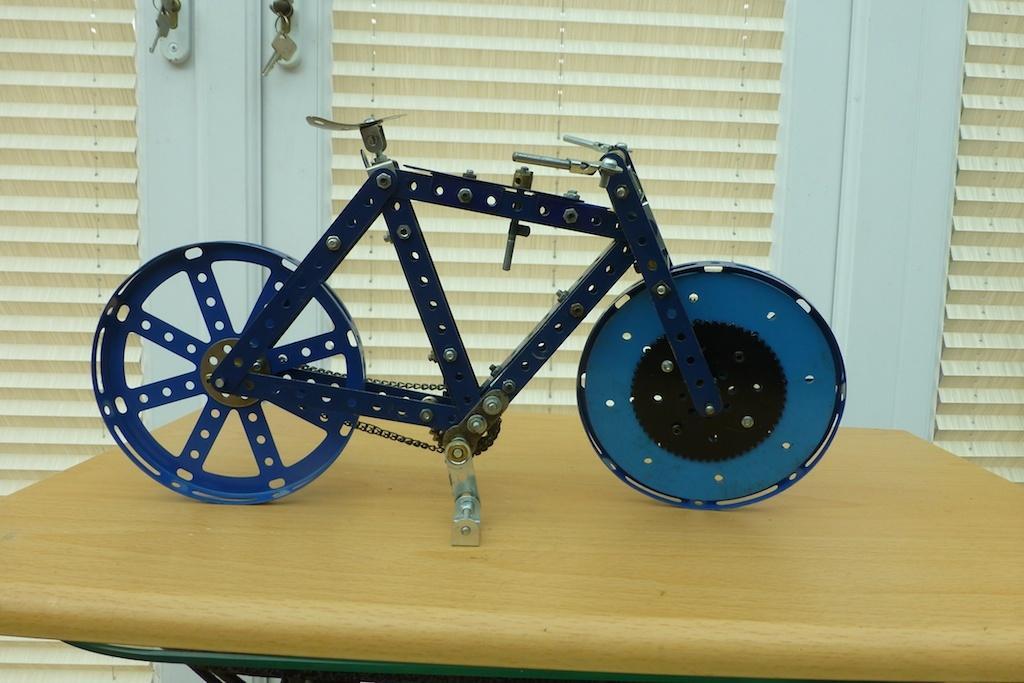In one or two sentences, can you explain what this image depicts? In this picture I can see a toy bicycle is placed on the wooden table, behind we can see the window. 